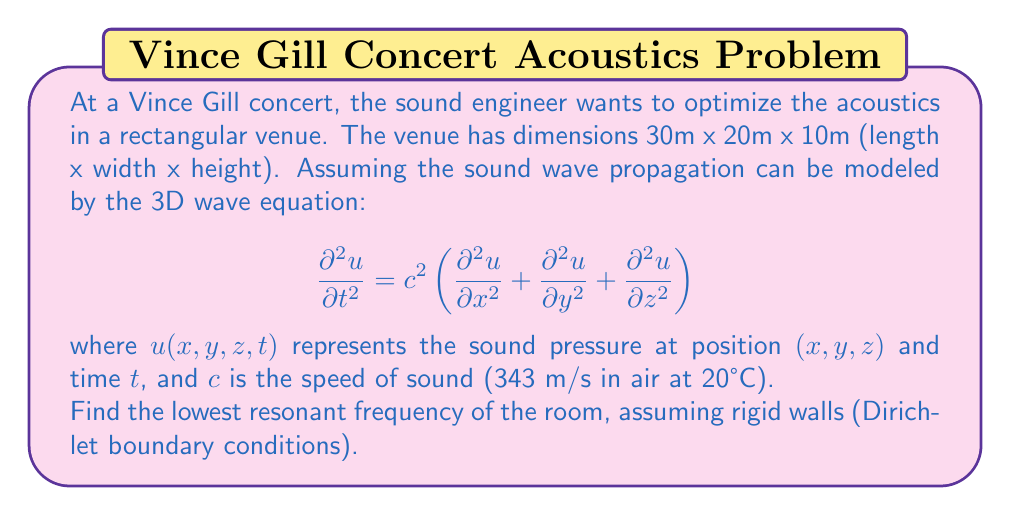Teach me how to tackle this problem. To solve this problem, we need to follow these steps:

1) For a rectangular room with rigid walls, the solution to the wave equation takes the form:

   $$u(x,y,z,t) = \sin(\frac{n_x\pi x}{L_x})\sin(\frac{n_y\pi y}{L_y})\sin(\frac{n_z\pi z}{L_z})\cos(\omega t)$$

   where $L_x$, $L_y$, and $L_z$ are the room dimensions, and $n_x$, $n_y$, and $n_z$ are positive integers.

2) Substituting this into the wave equation, we get:

   $$\omega^2 = c^2\pi^2\left(\frac{n_x^2}{L_x^2} + \frac{n_y^2}{L_y^2} + \frac{n_z^2}{L_z^2}\right)$$

3) The resonant frequencies are given by:

   $$f = \frac{\omega}{2\pi} = \frac{c}{2}\sqrt{\left(\frac{n_x}{L_x}\right)^2 + \left(\frac{n_y}{L_y}\right)^2 + \left(\frac{n_z}{L_z}\right)^2}$$

4) The lowest resonant frequency occurs when $n_x = 1$, $n_y = 1$, and $n_z = 1$. Substituting the given values:

   $$f = \frac{343}{2}\sqrt{\left(\frac{1}{30}\right)^2 + \left(\frac{1}{20}\right)^2 + \left(\frac{1}{10}\right)^2}$$

5) Simplifying:

   $$f = 171.5\sqrt{\frac{1}{900} + \frac{1}{400} + \frac{1}{100}} = 171.5\sqrt{0.0136111} \approx 20.0 \text{ Hz}$$

Therefore, the lowest resonant frequency of the room is approximately 20.0 Hz.
Answer: The lowest resonant frequency of the room is approximately 20.0 Hz. 